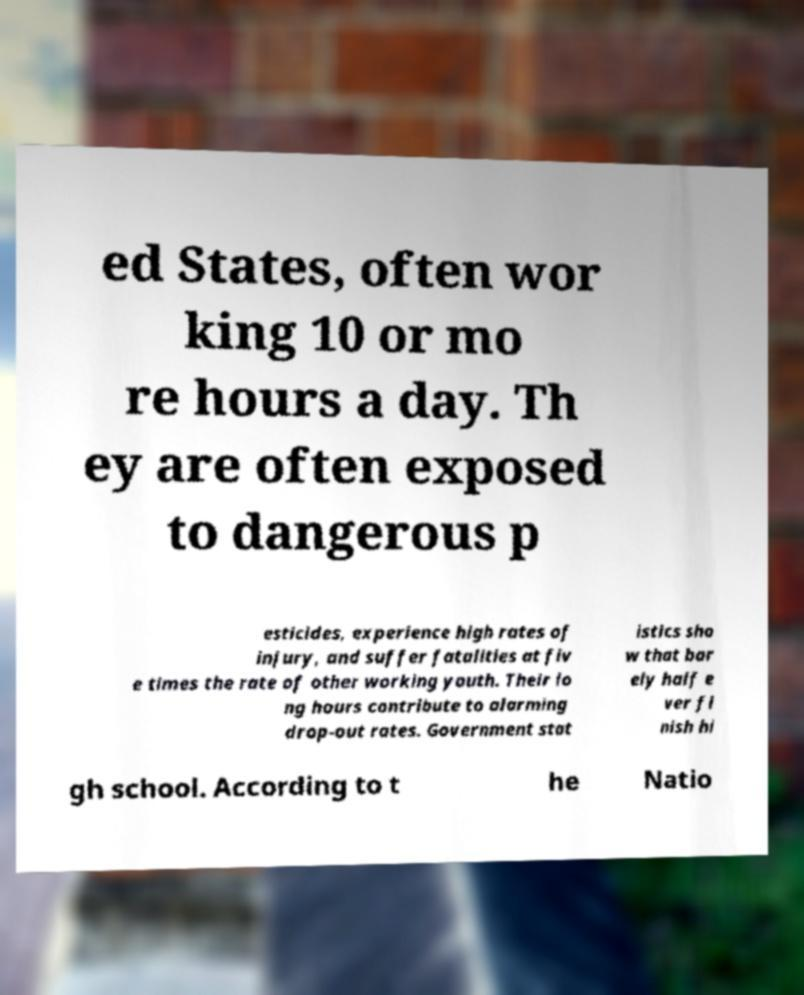There's text embedded in this image that I need extracted. Can you transcribe it verbatim? ed States, often wor king 10 or mo re hours a day. Th ey are often exposed to dangerous p esticides, experience high rates of injury, and suffer fatalities at fiv e times the rate of other working youth. Their lo ng hours contribute to alarming drop-out rates. Government stat istics sho w that bar ely half e ver fi nish hi gh school. According to t he Natio 